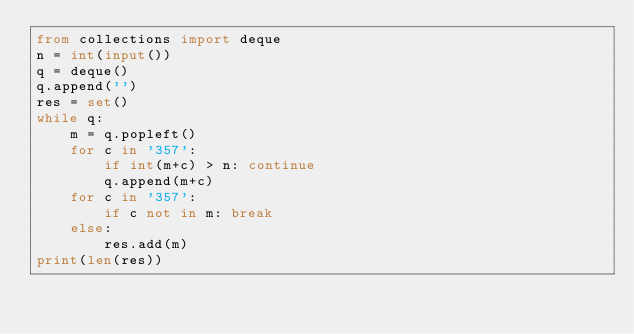Convert code to text. <code><loc_0><loc_0><loc_500><loc_500><_Python_>from collections import deque
n = int(input())
q = deque()
q.append('')
res = set()
while q:
    m = q.popleft()
    for c in '357':
        if int(m+c) > n: continue
        q.append(m+c)
    for c in '357':
        if c not in m: break
    else:
        res.add(m)
print(len(res))
</code> 